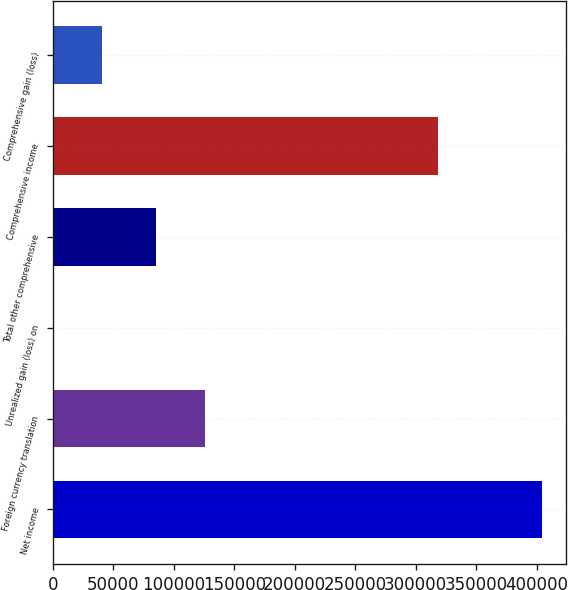Convert chart. <chart><loc_0><loc_0><loc_500><loc_500><bar_chart><fcel>Net income<fcel>Foreign currency translation<fcel>Unrealized gain (loss) on<fcel>Total other comprehensive<fcel>Comprehensive income<fcel>Comprehensive gain (loss)<nl><fcel>404169<fcel>125980<fcel>15<fcel>85565<fcel>318475<fcel>40430.4<nl></chart> 